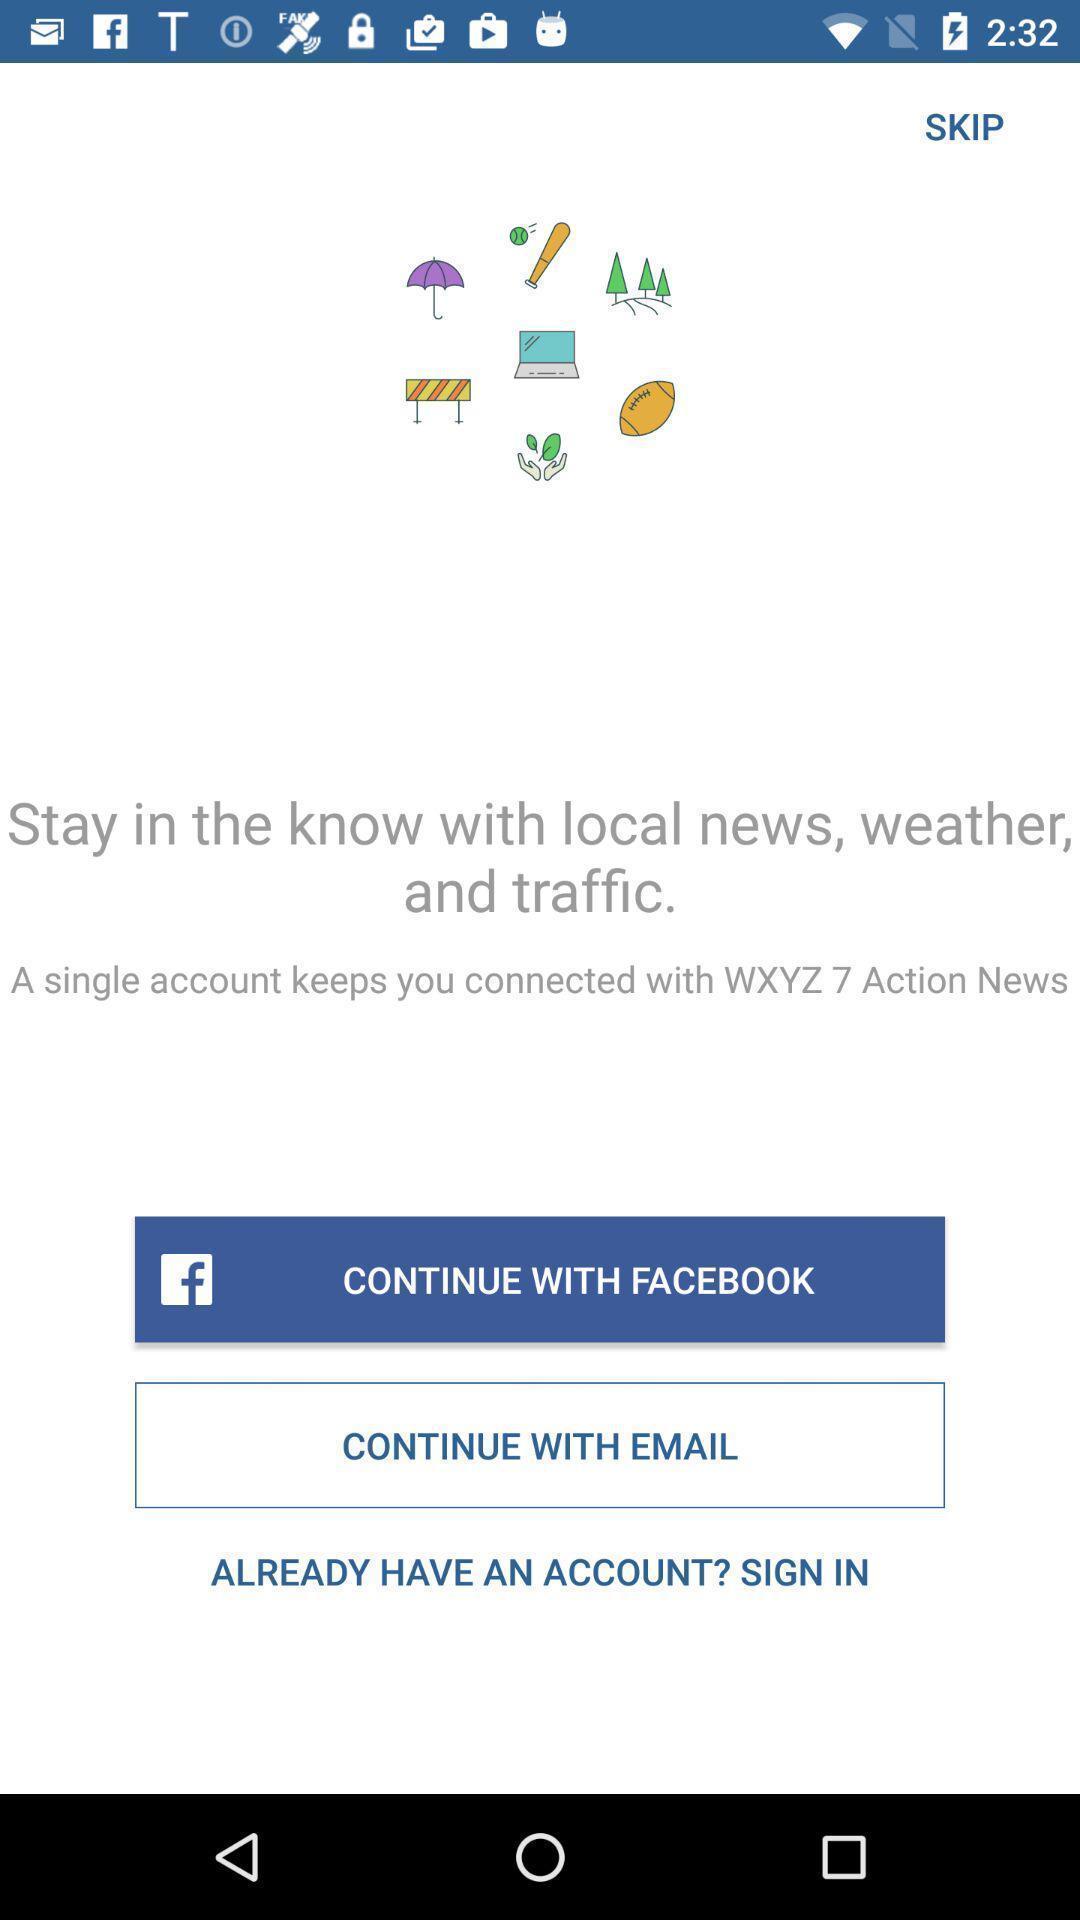What can you discern from this picture? Sign in page of a social app. 